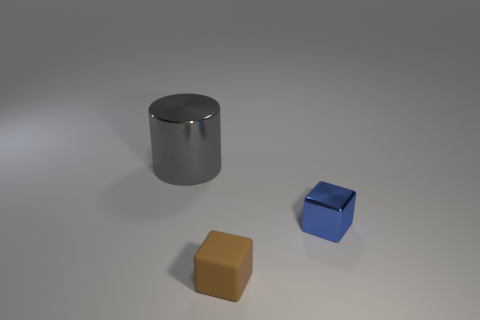Is there anything else that is the same size as the gray thing?
Offer a terse response. No. Are there more objects to the left of the small brown matte block than small brown metallic blocks?
Make the answer very short. Yes. How many small brown cubes are behind the tiny metal block?
Your answer should be compact. 0. Is there a blue metal cube of the same size as the gray shiny thing?
Give a very brief answer. No. The other small thing that is the same shape as the brown rubber thing is what color?
Your answer should be compact. Blue. Does the shiny thing that is to the right of the gray shiny thing have the same size as the shiny thing that is behind the small blue cube?
Your response must be concise. No. Is there a brown object that has the same shape as the gray shiny thing?
Offer a terse response. No. Are there an equal number of gray metallic cylinders that are right of the big gray metallic object and brown rubber blocks?
Keep it short and to the point. No. Is the size of the blue cube the same as the metallic object left of the metallic cube?
Give a very brief answer. No. What number of large gray cylinders have the same material as the small blue thing?
Ensure brevity in your answer.  1. 